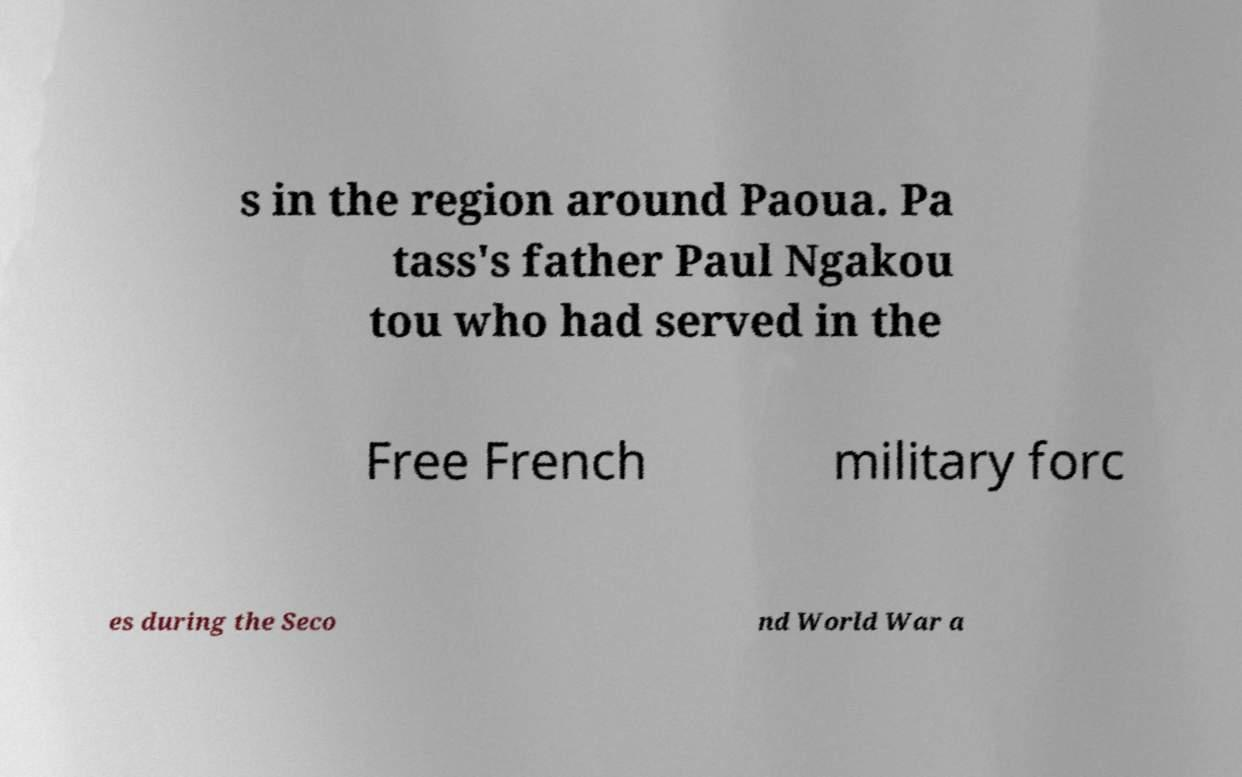I need the written content from this picture converted into text. Can you do that? s in the region around Paoua. Pa tass's father Paul Ngakou tou who had served in the Free French military forc es during the Seco nd World War a 